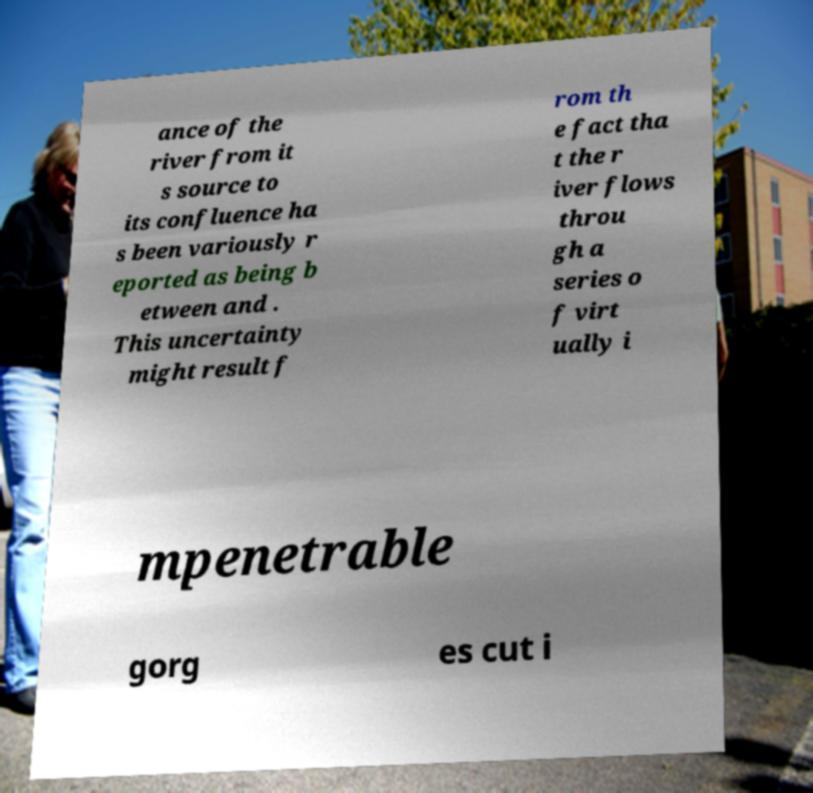Could you extract and type out the text from this image? ance of the river from it s source to its confluence ha s been variously r eported as being b etween and . This uncertainty might result f rom th e fact tha t the r iver flows throu gh a series o f virt ually i mpenetrable gorg es cut i 